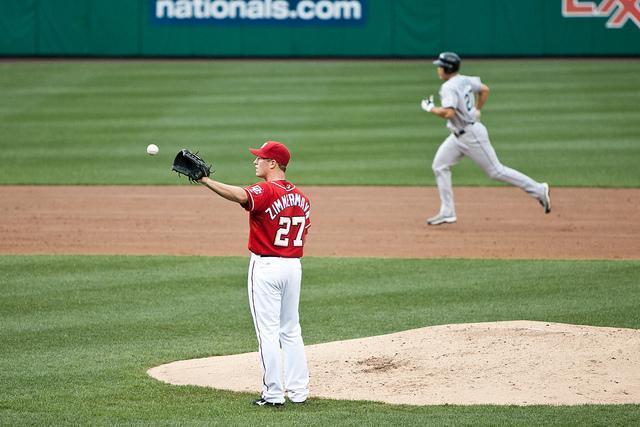How many stripes are on each man's pants?
Give a very brief answer. 1. How many people can be seen?
Give a very brief answer. 2. How many birds are seen?
Give a very brief answer. 0. 